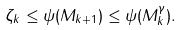Convert formula to latex. <formula><loc_0><loc_0><loc_500><loc_500>\zeta _ { k } \leq \psi ( M _ { k + 1 } ) \leq \psi ( M _ { k } ^ { \gamma } ) .</formula> 